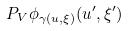<formula> <loc_0><loc_0><loc_500><loc_500>P _ { V } \phi _ { \gamma ( u , \xi ) } ( u ^ { \prime } , \xi ^ { \prime } )</formula> 